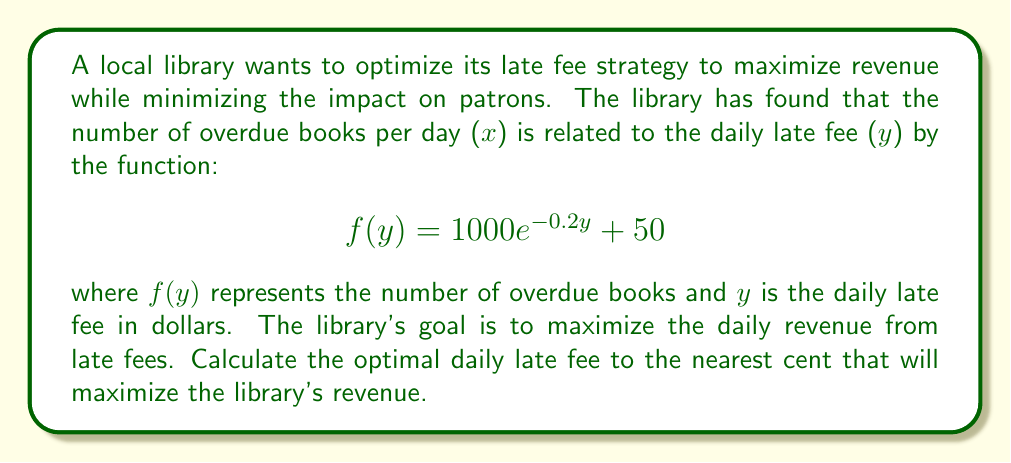Solve this math problem. To solve this optimization problem, we need to follow these steps:

1) The daily revenue $R(y)$ is the product of the number of overdue books and the late fee:

   $$R(y) = y \cdot f(y) = y(1000e^{-0.2y} + 50)$$

2) To find the maximum revenue, we need to find the value of $y$ where the derivative of $R(y)$ equals zero:

   $$\frac{dR}{dy} = (1000e^{-0.2y} + 50) + y(-200e^{-0.2y}) = 0$$

3) Simplify the equation:

   $$1000e^{-0.2y} + 50 - 200ye^{-0.2y} = 0$$

4) Divide by $e^{-0.2y}$:

   $$1000 + 50e^{0.2y} - 200y = 0$$

5) This equation cannot be solved algebraically. We need to use numerical methods, such as Newton's method or graphical analysis.

6) Using a graphing calculator or computer software, we can find that the solution to this equation is approximately $y \approx 5.9644$.

7) To verify this is a maximum, we can check the second derivative is negative at this point.

8) Rounding to the nearest cent gives us $y = 5.96$.
Answer: The optimal daily late fee that maximizes the library's revenue is $5.96. 